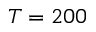Convert formula to latex. <formula><loc_0><loc_0><loc_500><loc_500>T = 2 0 0</formula> 